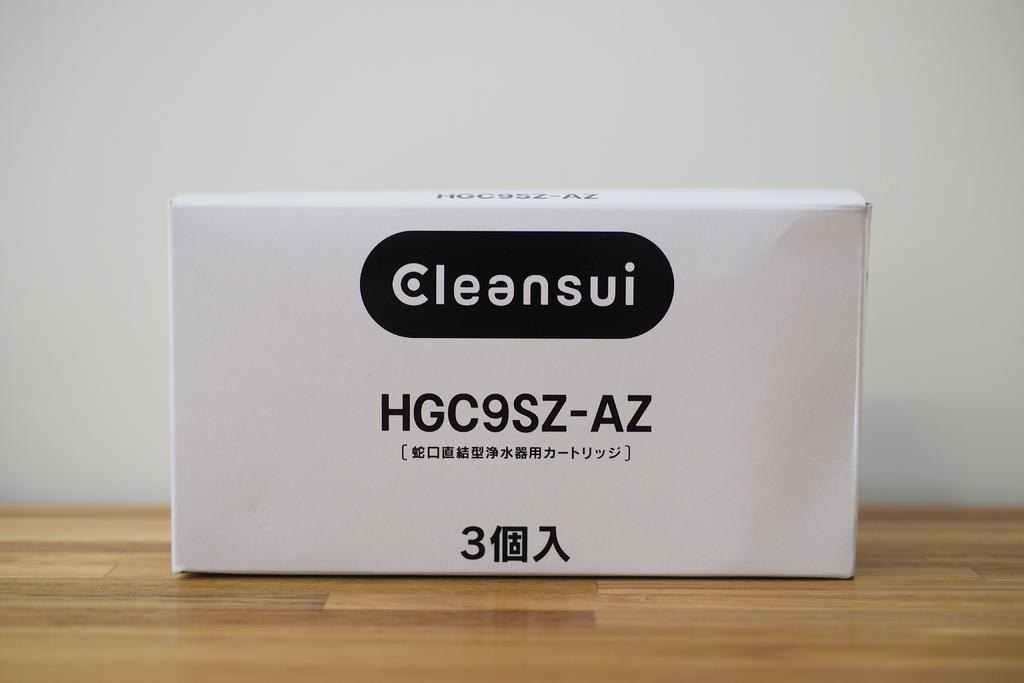<image>
Offer a succinct explanation of the picture presented. Cleansui HGC9SZ-AZ is the brand number shown on the side of this box. 